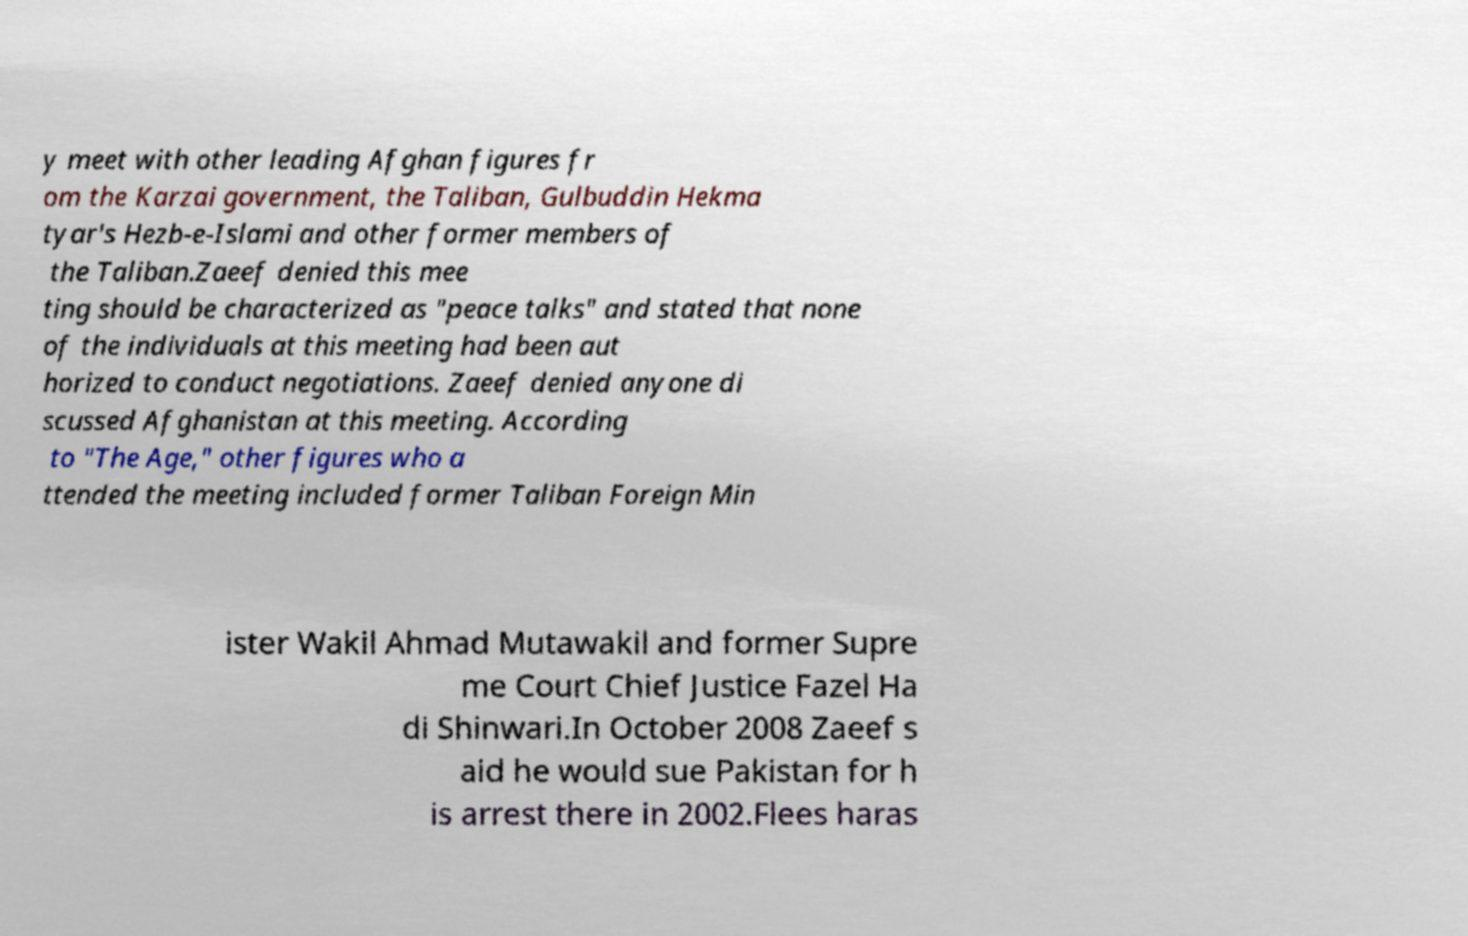Could you extract and type out the text from this image? y meet with other leading Afghan figures fr om the Karzai government, the Taliban, Gulbuddin Hekma tyar's Hezb-e-Islami and other former members of the Taliban.Zaeef denied this mee ting should be characterized as "peace talks" and stated that none of the individuals at this meeting had been aut horized to conduct negotiations. Zaeef denied anyone di scussed Afghanistan at this meeting. According to "The Age," other figures who a ttended the meeting included former Taliban Foreign Min ister Wakil Ahmad Mutawakil and former Supre me Court Chief Justice Fazel Ha di Shinwari.In October 2008 Zaeef s aid he would sue Pakistan for h is arrest there in 2002.Flees haras 